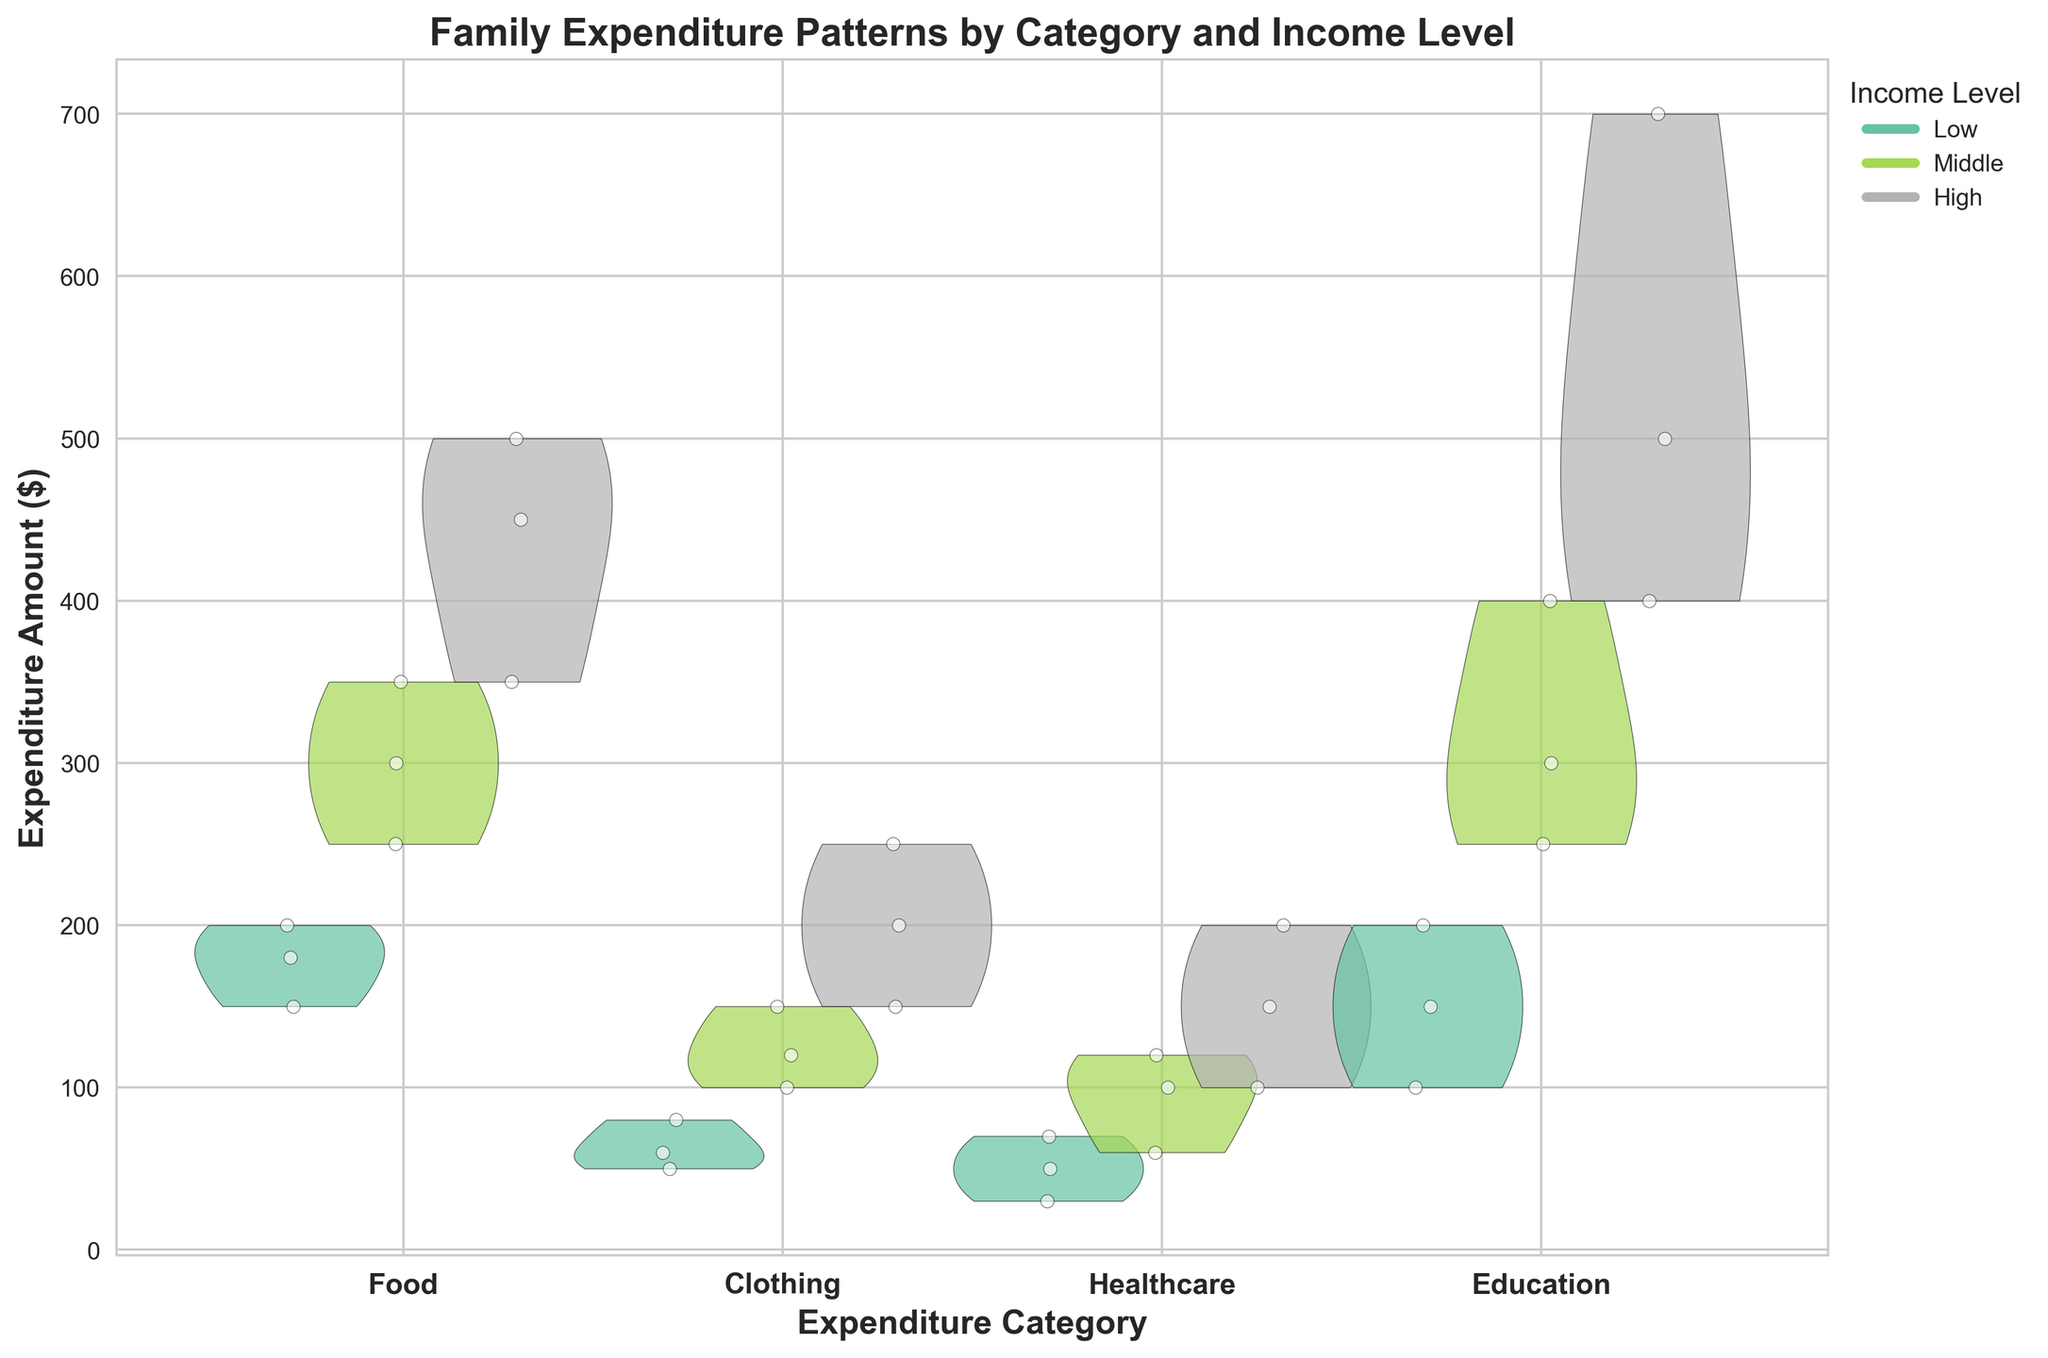What is the title of the figure? The title of the figure is located at the top of the plot. It describes the main topic of the visualization, providing an immediate understanding of what the chart represents.
Answer: Family Expenditure Patterns by Category and Income Level How many income levels are represented in the figure? The income levels can be identified by looking at the different colored areas and checking the legend on the right side of the plot. Each unique color indicates a different income level.
Answer: 3 Which expenditure category has the widest variation in expenditure amounts for high-income families? By examining the shapes of the violin plots for high-income families (indicated by one of the colors), you can see which category has the most spread-out violin plot, indicating the widest variation.
Answer: Education Compare the expenditure amounts between Middle and High income levels for the Healthcare category in the Elementary stage. Which one is higher on average? Look at the violin plots and the scatter points for Healthcare in the Elementary stage for both Middle and High income levels. Assess the central tendency of the data (like the mean position of the scatter points within the violins) to determine which income group spends more.
Answer: High income Which expenditure category shows the least expenditure for low-income families? The least expenditure can be identified by looking at the lowest positions of the scatter points within the violin plots for low-income families.
Answer: Healthcare In which category does the expenditure significantly increase as the income level rises? By evaluating how the positions and shapes of the violins change across income levels for each category, you can identify the one where expenditures consistently rise.
Answer: Education What is the general trend of food expenditure across different education stages and income levels? Observe the food expenditure violin plots across all stages and income levels to see if there is a consistent pattern or change. For instance, check if expenditures increase with higher income or at different education stages.
Answer: Increases with both higher income and education stage How does the variation in clothing expenditure compare between low and middle income levels? Compare the spread of the violin plots for the clothing expenditure category between low and middle income levels. The wider the violin plot, the greater the variation.
Answer: Middle income has more variation In the pre-school stage, which expenditure category shows the highest expenditure for Middle income families? Look at the peak (highest point on the y-axis) within the violin plots for the pre-school stage for Middle income families to determine the highest expenditure.
Answer: Education Which category shows the smallest expenditure change between Middle and High income levels? Compare the violin plots for different categories between Middle and High income levels. Assess which has the smallest change in central tendency or spread.
Answer: Healthcare 